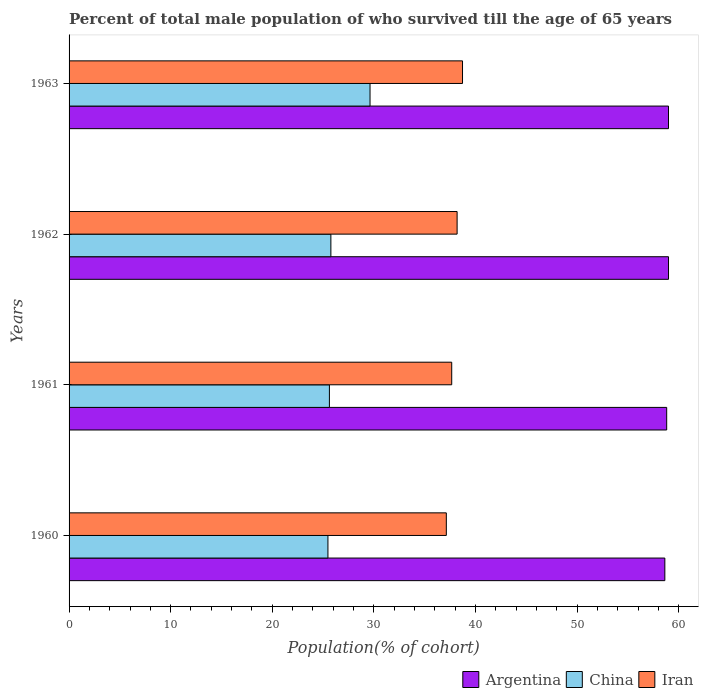How many groups of bars are there?
Your answer should be compact. 4. Are the number of bars per tick equal to the number of legend labels?
Ensure brevity in your answer.  Yes. Are the number of bars on each tick of the Y-axis equal?
Provide a short and direct response. Yes. What is the label of the 3rd group of bars from the top?
Ensure brevity in your answer.  1961. In how many cases, is the number of bars for a given year not equal to the number of legend labels?
Your answer should be very brief. 0. What is the percentage of total male population who survived till the age of 65 years in Argentina in 1963?
Provide a short and direct response. 59. Across all years, what is the maximum percentage of total male population who survived till the age of 65 years in Argentina?
Make the answer very short. 59. Across all years, what is the minimum percentage of total male population who survived till the age of 65 years in China?
Give a very brief answer. 25.48. What is the total percentage of total male population who survived till the age of 65 years in Iran in the graph?
Your response must be concise. 151.71. What is the difference between the percentage of total male population who survived till the age of 65 years in China in 1960 and that in 1962?
Offer a very short reply. -0.29. What is the difference between the percentage of total male population who survived till the age of 65 years in Argentina in 1962 and the percentage of total male population who survived till the age of 65 years in China in 1963?
Make the answer very short. 29.38. What is the average percentage of total male population who survived till the age of 65 years in Iran per year?
Give a very brief answer. 37.93. In the year 1963, what is the difference between the percentage of total male population who survived till the age of 65 years in Argentina and percentage of total male population who survived till the age of 65 years in Iran?
Provide a short and direct response. 20.27. What is the ratio of the percentage of total male population who survived till the age of 65 years in Iran in 1960 to that in 1962?
Ensure brevity in your answer.  0.97. What is the difference between the highest and the second highest percentage of total male population who survived till the age of 65 years in China?
Your answer should be compact. 3.85. What is the difference between the highest and the lowest percentage of total male population who survived till the age of 65 years in Argentina?
Make the answer very short. 0.36. Is it the case that in every year, the sum of the percentage of total male population who survived till the age of 65 years in Iran and percentage of total male population who survived till the age of 65 years in Argentina is greater than the percentage of total male population who survived till the age of 65 years in China?
Your answer should be very brief. Yes. Are all the bars in the graph horizontal?
Ensure brevity in your answer.  Yes. What is the difference between two consecutive major ticks on the X-axis?
Provide a succinct answer. 10. Does the graph contain any zero values?
Make the answer very short. No. What is the title of the graph?
Provide a short and direct response. Percent of total male population of who survived till the age of 65 years. Does "Liechtenstein" appear as one of the legend labels in the graph?
Provide a short and direct response. No. What is the label or title of the X-axis?
Give a very brief answer. Population(% of cohort). What is the label or title of the Y-axis?
Provide a succinct answer. Years. What is the Population(% of cohort) in Argentina in 1960?
Your answer should be compact. 58.64. What is the Population(% of cohort) in China in 1960?
Your answer should be compact. 25.48. What is the Population(% of cohort) of Iran in 1960?
Ensure brevity in your answer.  37.13. What is the Population(% of cohort) in Argentina in 1961?
Offer a very short reply. 58.82. What is the Population(% of cohort) in China in 1961?
Provide a succinct answer. 25.62. What is the Population(% of cohort) in Iran in 1961?
Give a very brief answer. 37.66. What is the Population(% of cohort) in Argentina in 1962?
Ensure brevity in your answer.  59. What is the Population(% of cohort) of China in 1962?
Offer a terse response. 25.77. What is the Population(% of cohort) in Iran in 1962?
Offer a very short reply. 38.19. What is the Population(% of cohort) in Argentina in 1963?
Your answer should be very brief. 59. What is the Population(% of cohort) of China in 1963?
Ensure brevity in your answer.  29.62. What is the Population(% of cohort) in Iran in 1963?
Provide a succinct answer. 38.73. Across all years, what is the maximum Population(% of cohort) of Argentina?
Your answer should be compact. 59. Across all years, what is the maximum Population(% of cohort) in China?
Provide a succinct answer. 29.62. Across all years, what is the maximum Population(% of cohort) of Iran?
Your answer should be compact. 38.73. Across all years, what is the minimum Population(% of cohort) in Argentina?
Ensure brevity in your answer.  58.64. Across all years, what is the minimum Population(% of cohort) of China?
Offer a terse response. 25.48. Across all years, what is the minimum Population(% of cohort) of Iran?
Ensure brevity in your answer.  37.13. What is the total Population(% of cohort) in Argentina in the graph?
Ensure brevity in your answer.  235.46. What is the total Population(% of cohort) in China in the graph?
Offer a very short reply. 106.49. What is the total Population(% of cohort) of Iran in the graph?
Keep it short and to the point. 151.71. What is the difference between the Population(% of cohort) of Argentina in 1960 and that in 1961?
Your response must be concise. -0.18. What is the difference between the Population(% of cohort) of China in 1960 and that in 1961?
Make the answer very short. -0.14. What is the difference between the Population(% of cohort) in Iran in 1960 and that in 1961?
Your answer should be very brief. -0.53. What is the difference between the Population(% of cohort) of Argentina in 1960 and that in 1962?
Provide a short and direct response. -0.36. What is the difference between the Population(% of cohort) in China in 1960 and that in 1962?
Your answer should be compact. -0.29. What is the difference between the Population(% of cohort) of Iran in 1960 and that in 1962?
Offer a very short reply. -1.06. What is the difference between the Population(% of cohort) in Argentina in 1960 and that in 1963?
Your answer should be very brief. -0.36. What is the difference between the Population(% of cohort) in China in 1960 and that in 1963?
Your answer should be very brief. -4.14. What is the difference between the Population(% of cohort) in Iran in 1960 and that in 1963?
Provide a succinct answer. -1.59. What is the difference between the Population(% of cohort) of Argentina in 1961 and that in 1962?
Make the answer very short. -0.18. What is the difference between the Population(% of cohort) in China in 1961 and that in 1962?
Your answer should be very brief. -0.14. What is the difference between the Population(% of cohort) in Iran in 1961 and that in 1962?
Your response must be concise. -0.53. What is the difference between the Population(% of cohort) of Argentina in 1961 and that in 1963?
Provide a short and direct response. -0.18. What is the difference between the Population(% of cohort) in China in 1961 and that in 1963?
Make the answer very short. -4. What is the difference between the Population(% of cohort) in Iran in 1961 and that in 1963?
Your response must be concise. -1.06. What is the difference between the Population(% of cohort) of Argentina in 1962 and that in 1963?
Keep it short and to the point. 0. What is the difference between the Population(% of cohort) of China in 1962 and that in 1963?
Your answer should be compact. -3.85. What is the difference between the Population(% of cohort) of Iran in 1962 and that in 1963?
Keep it short and to the point. -0.53. What is the difference between the Population(% of cohort) in Argentina in 1960 and the Population(% of cohort) in China in 1961?
Your response must be concise. 33.02. What is the difference between the Population(% of cohort) in Argentina in 1960 and the Population(% of cohort) in Iran in 1961?
Offer a terse response. 20.98. What is the difference between the Population(% of cohort) of China in 1960 and the Population(% of cohort) of Iran in 1961?
Make the answer very short. -12.18. What is the difference between the Population(% of cohort) in Argentina in 1960 and the Population(% of cohort) in China in 1962?
Your answer should be very brief. 32.87. What is the difference between the Population(% of cohort) of Argentina in 1960 and the Population(% of cohort) of Iran in 1962?
Make the answer very short. 20.45. What is the difference between the Population(% of cohort) in China in 1960 and the Population(% of cohort) in Iran in 1962?
Make the answer very short. -12.71. What is the difference between the Population(% of cohort) of Argentina in 1960 and the Population(% of cohort) of China in 1963?
Offer a very short reply. 29.02. What is the difference between the Population(% of cohort) of Argentina in 1960 and the Population(% of cohort) of Iran in 1963?
Make the answer very short. 19.91. What is the difference between the Population(% of cohort) in China in 1960 and the Population(% of cohort) in Iran in 1963?
Provide a short and direct response. -13.25. What is the difference between the Population(% of cohort) of Argentina in 1961 and the Population(% of cohort) of China in 1962?
Offer a very short reply. 33.05. What is the difference between the Population(% of cohort) in Argentina in 1961 and the Population(% of cohort) in Iran in 1962?
Give a very brief answer. 20.63. What is the difference between the Population(% of cohort) in China in 1961 and the Population(% of cohort) in Iran in 1962?
Keep it short and to the point. -12.57. What is the difference between the Population(% of cohort) of Argentina in 1961 and the Population(% of cohort) of China in 1963?
Your response must be concise. 29.2. What is the difference between the Population(% of cohort) of Argentina in 1961 and the Population(% of cohort) of Iran in 1963?
Your answer should be very brief. 20.09. What is the difference between the Population(% of cohort) of China in 1961 and the Population(% of cohort) of Iran in 1963?
Provide a short and direct response. -13.1. What is the difference between the Population(% of cohort) of Argentina in 1962 and the Population(% of cohort) of China in 1963?
Your answer should be very brief. 29.38. What is the difference between the Population(% of cohort) in Argentina in 1962 and the Population(% of cohort) in Iran in 1963?
Offer a very short reply. 20.28. What is the difference between the Population(% of cohort) of China in 1962 and the Population(% of cohort) of Iran in 1963?
Make the answer very short. -12.96. What is the average Population(% of cohort) in Argentina per year?
Your answer should be compact. 58.87. What is the average Population(% of cohort) of China per year?
Your answer should be compact. 26.62. What is the average Population(% of cohort) of Iran per year?
Provide a succinct answer. 37.93. In the year 1960, what is the difference between the Population(% of cohort) in Argentina and Population(% of cohort) in China?
Make the answer very short. 33.16. In the year 1960, what is the difference between the Population(% of cohort) of Argentina and Population(% of cohort) of Iran?
Provide a short and direct response. 21.51. In the year 1960, what is the difference between the Population(% of cohort) in China and Population(% of cohort) in Iran?
Offer a terse response. -11.65. In the year 1961, what is the difference between the Population(% of cohort) of Argentina and Population(% of cohort) of China?
Provide a short and direct response. 33.2. In the year 1961, what is the difference between the Population(% of cohort) of Argentina and Population(% of cohort) of Iran?
Provide a succinct answer. 21.16. In the year 1961, what is the difference between the Population(% of cohort) of China and Population(% of cohort) of Iran?
Provide a succinct answer. -12.04. In the year 1962, what is the difference between the Population(% of cohort) in Argentina and Population(% of cohort) in China?
Give a very brief answer. 33.23. In the year 1962, what is the difference between the Population(% of cohort) in Argentina and Population(% of cohort) in Iran?
Offer a very short reply. 20.81. In the year 1962, what is the difference between the Population(% of cohort) in China and Population(% of cohort) in Iran?
Your answer should be very brief. -12.43. In the year 1963, what is the difference between the Population(% of cohort) of Argentina and Population(% of cohort) of China?
Make the answer very short. 29.38. In the year 1963, what is the difference between the Population(% of cohort) of Argentina and Population(% of cohort) of Iran?
Your answer should be very brief. 20.27. In the year 1963, what is the difference between the Population(% of cohort) of China and Population(% of cohort) of Iran?
Give a very brief answer. -9.1. What is the ratio of the Population(% of cohort) in Argentina in 1960 to that in 1961?
Provide a short and direct response. 1. What is the ratio of the Population(% of cohort) of Iran in 1960 to that in 1961?
Your answer should be compact. 0.99. What is the ratio of the Population(% of cohort) of Argentina in 1960 to that in 1962?
Offer a very short reply. 0.99. What is the ratio of the Population(% of cohort) of Iran in 1960 to that in 1962?
Keep it short and to the point. 0.97. What is the ratio of the Population(% of cohort) of China in 1960 to that in 1963?
Offer a terse response. 0.86. What is the ratio of the Population(% of cohort) in Iran in 1960 to that in 1963?
Offer a very short reply. 0.96. What is the ratio of the Population(% of cohort) of Argentina in 1961 to that in 1962?
Your answer should be very brief. 1. What is the ratio of the Population(% of cohort) in China in 1961 to that in 1962?
Offer a terse response. 0.99. What is the ratio of the Population(% of cohort) of Iran in 1961 to that in 1962?
Ensure brevity in your answer.  0.99. What is the ratio of the Population(% of cohort) of Argentina in 1961 to that in 1963?
Make the answer very short. 1. What is the ratio of the Population(% of cohort) of China in 1961 to that in 1963?
Provide a succinct answer. 0.86. What is the ratio of the Population(% of cohort) of Iran in 1961 to that in 1963?
Give a very brief answer. 0.97. What is the ratio of the Population(% of cohort) in Argentina in 1962 to that in 1963?
Ensure brevity in your answer.  1. What is the ratio of the Population(% of cohort) in China in 1962 to that in 1963?
Offer a terse response. 0.87. What is the ratio of the Population(% of cohort) in Iran in 1962 to that in 1963?
Provide a short and direct response. 0.99. What is the difference between the highest and the second highest Population(% of cohort) of Argentina?
Ensure brevity in your answer.  0. What is the difference between the highest and the second highest Population(% of cohort) of China?
Offer a terse response. 3.85. What is the difference between the highest and the second highest Population(% of cohort) of Iran?
Offer a terse response. 0.53. What is the difference between the highest and the lowest Population(% of cohort) of Argentina?
Provide a succinct answer. 0.36. What is the difference between the highest and the lowest Population(% of cohort) of China?
Your response must be concise. 4.14. What is the difference between the highest and the lowest Population(% of cohort) in Iran?
Ensure brevity in your answer.  1.59. 